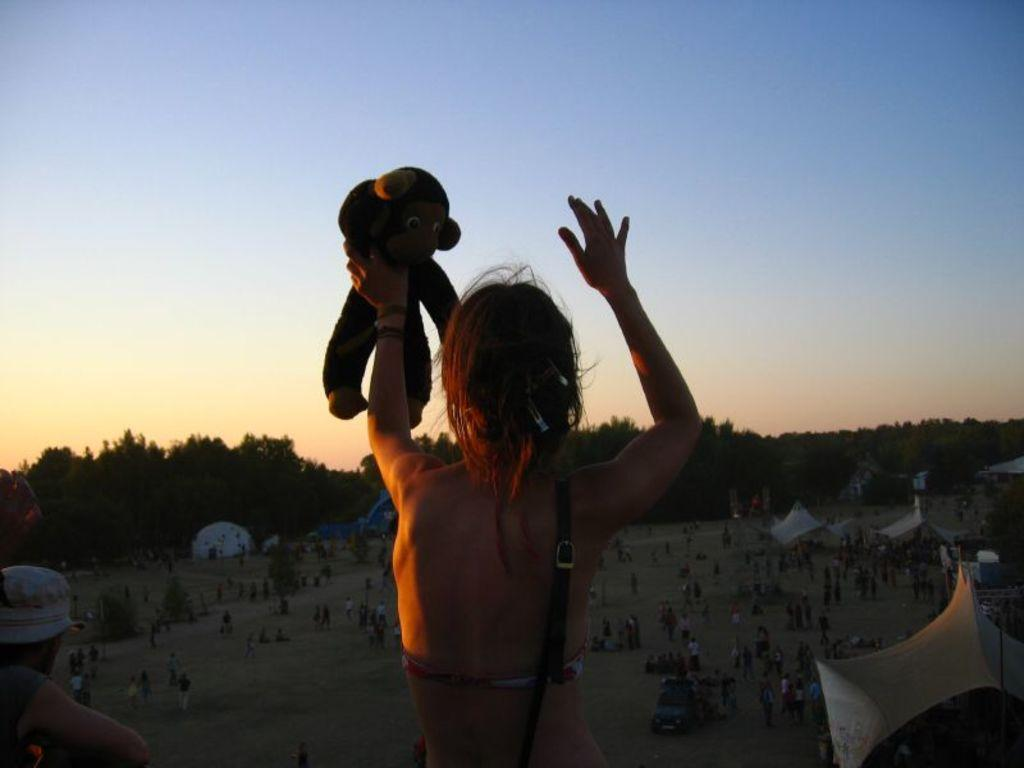What is the person in the image doing? The person is standing in the image and holding a toy. Can you describe the surroundings of the person? There are other persons visible in the background, as well as trees and the sky. What colors can be seen in the sky? The sky is visible in the background with blue and white colors. What type of silk fabric is draped over the person's eyes in the image? There is no silk fabric or any fabric covering the person's eyes in the image. 